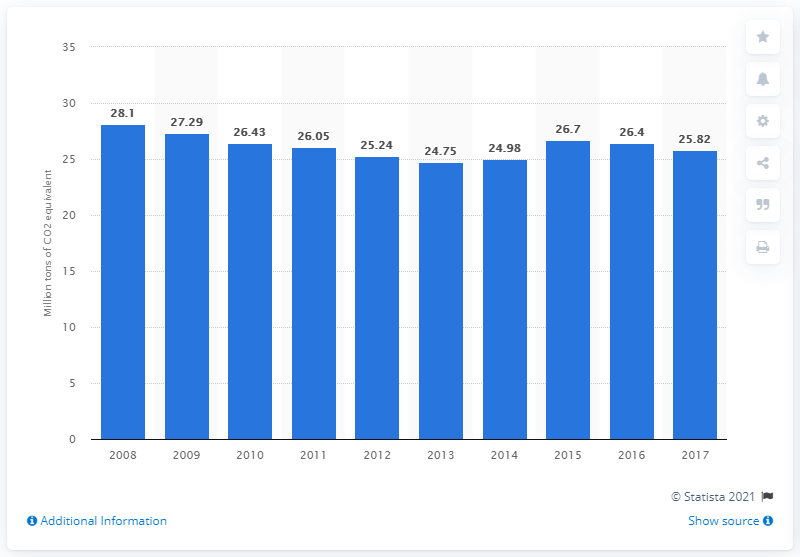Indicate a few pertinent items in this graphic. In 2017, fuel combustion in Belgium emitted a total of 25.82 metric tons of CO2 equivalent. 